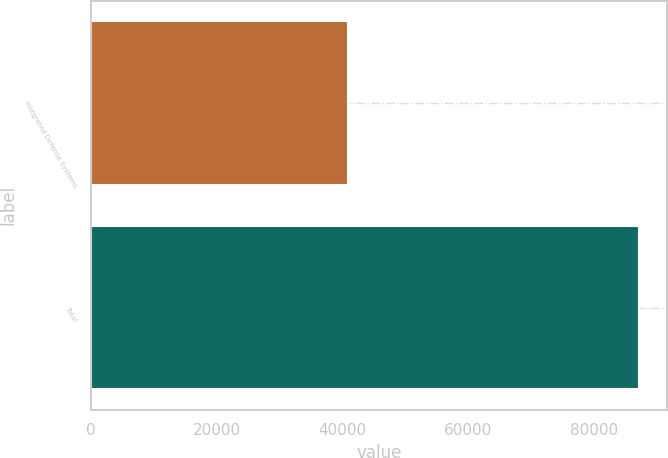Convert chart. <chart><loc_0><loc_0><loc_500><loc_500><bar_chart><fcel>Integrated Defense Systems<fcel>Total<nl><fcel>40950<fcel>87181<nl></chart> 